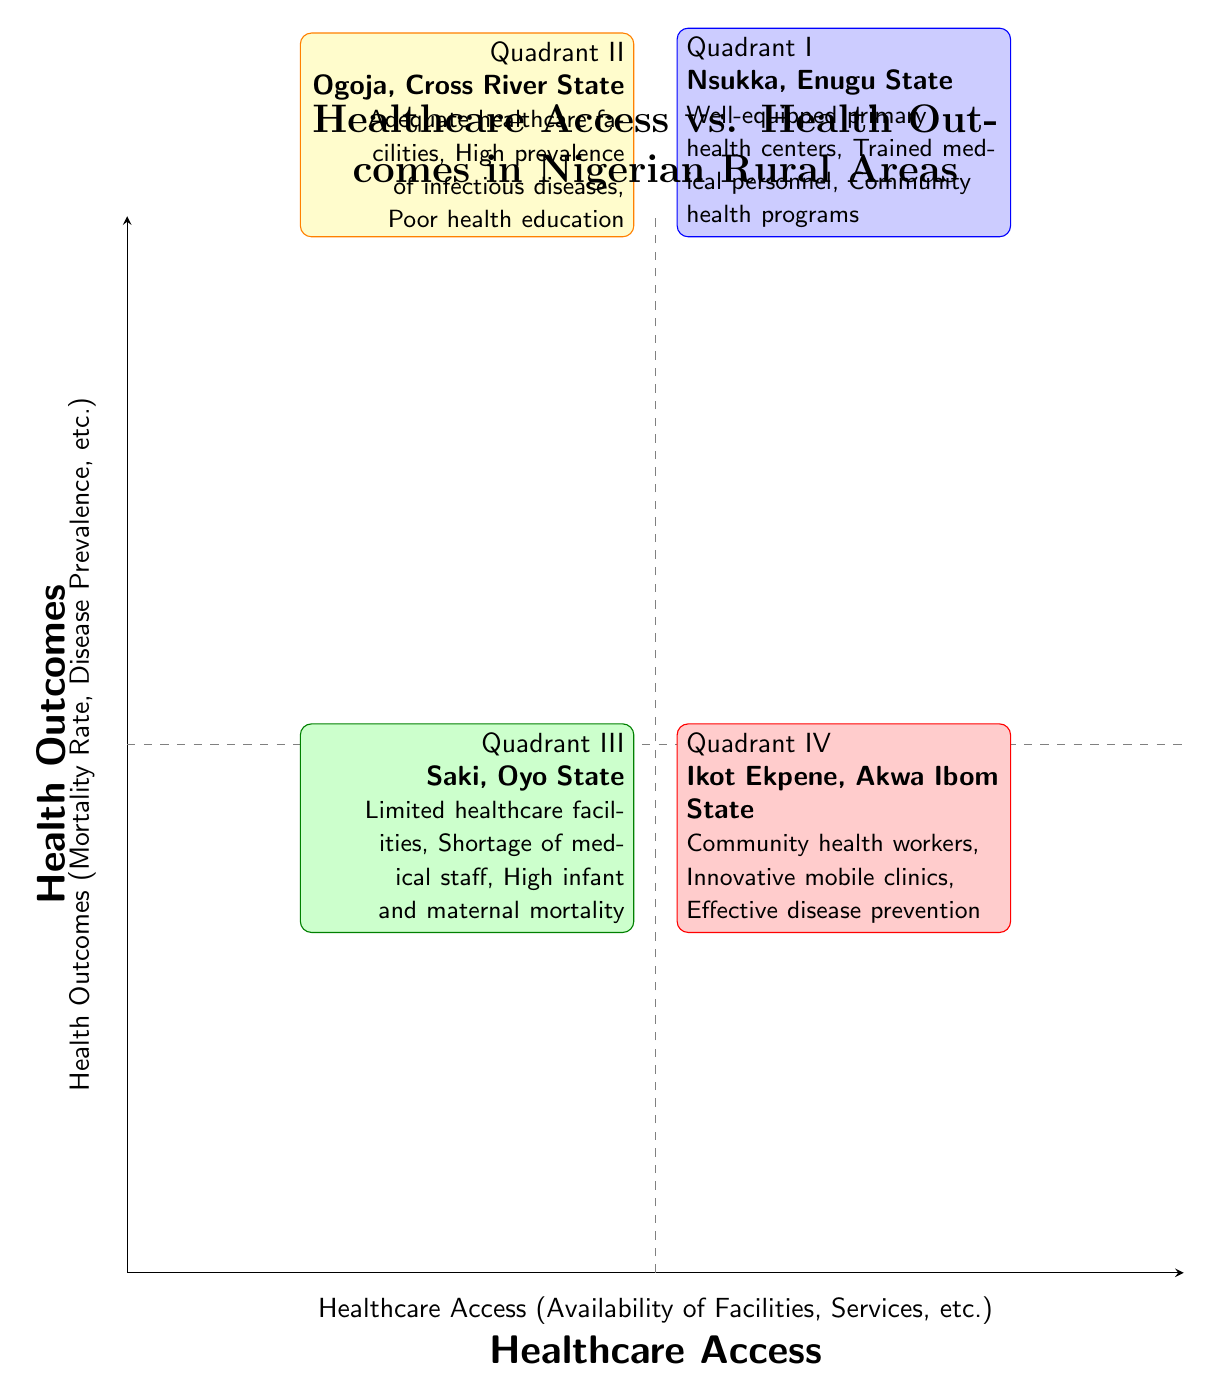What are the characteristics of regions in Quadrant I? Quadrant I represents regions with high healthcare access and good health outcomes. Specifically, the characteristics listed for Nsukka, Enugu State include well-equipped primary health centers, trained medical personnel, and community health programs.
Answer: Well-equipped primary health centers, trained medical personnel, community health programs Which quadrant is associated with Ogoja, Cross River State? Ogoja, Cross River State is an example in Quadrant II, which describes it as having high healthcare access but poor health outcomes.
Answer: Quadrant II How many regions are shown in Quadrant IV? Quadrant IV lists a single region, which is Ikot Ekpene, Akwa Ibom State.
Answer: 1 What is the primary issue indicated in Quadrant III? Quadrant III, which describes regions with low healthcare access and poor health outcomes, highlights issues like limited healthcare facilities, shortage of medical staff, and high infant and maternal mortality.
Answer: Limited healthcare facilities Which quadrant has the highest healthcare access? Quadrant I has the highest healthcare access as characterized by well-equipped primary health centers and trained medical personnel.
Answer: Quadrant I In terms of healthcare access and outcomes, what can be said about the relationship in Quadrant II? Quadrant II features high healthcare access but poor health outcomes due to factors like high prevalence of infectious diseases and poor health education. This presents a unique case where access does not equate to positive health results.
Answer: High healthcare access but poor health outcomes What region is located in Quadrant IV? The region located in Quadrant IV is Ikot Ekpene, Akwa Ibom State, which has low healthcare access yet shows good health outcomes.
Answer: Ikot Ekpene, Akwa Ibom State Which quadrant features innovative mobile clinics? Innovative mobile clinics are a characteristic of Quadrant IV, as indicated by the description of Ikot Ekpene, Akwa Ibom State.
Answer: Quadrant IV 